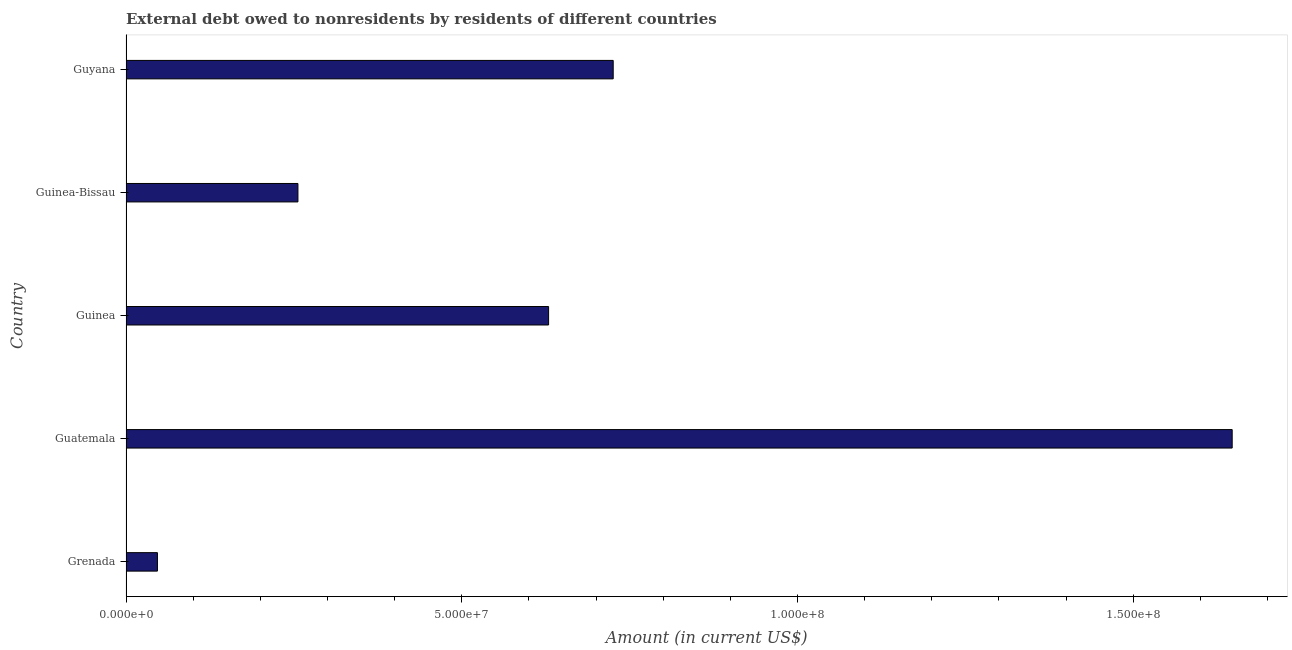Does the graph contain any zero values?
Offer a very short reply. No. Does the graph contain grids?
Ensure brevity in your answer.  No. What is the title of the graph?
Provide a succinct answer. External debt owed to nonresidents by residents of different countries. What is the label or title of the X-axis?
Provide a succinct answer. Amount (in current US$). What is the label or title of the Y-axis?
Offer a terse response. Country. What is the debt in Guinea-Bissau?
Offer a very short reply. 2.56e+07. Across all countries, what is the maximum debt?
Your answer should be very brief. 1.65e+08. Across all countries, what is the minimum debt?
Your response must be concise. 4.68e+06. In which country was the debt maximum?
Your answer should be very brief. Guatemala. In which country was the debt minimum?
Give a very brief answer. Grenada. What is the sum of the debt?
Keep it short and to the point. 3.31e+08. What is the difference between the debt in Guatemala and Guyana?
Your response must be concise. 9.22e+07. What is the average debt per country?
Offer a very short reply. 6.61e+07. What is the median debt?
Ensure brevity in your answer.  6.29e+07. In how many countries, is the debt greater than 60000000 US$?
Keep it short and to the point. 3. What is the ratio of the debt in Grenada to that in Guinea-Bissau?
Offer a terse response. 0.18. What is the difference between the highest and the second highest debt?
Provide a short and direct response. 9.22e+07. What is the difference between the highest and the lowest debt?
Provide a short and direct response. 1.60e+08. How many countries are there in the graph?
Provide a succinct answer. 5. Are the values on the major ticks of X-axis written in scientific E-notation?
Offer a terse response. Yes. What is the Amount (in current US$) of Grenada?
Make the answer very short. 4.68e+06. What is the Amount (in current US$) of Guatemala?
Provide a succinct answer. 1.65e+08. What is the Amount (in current US$) in Guinea?
Ensure brevity in your answer.  6.29e+07. What is the Amount (in current US$) of Guinea-Bissau?
Ensure brevity in your answer.  2.56e+07. What is the Amount (in current US$) of Guyana?
Ensure brevity in your answer.  7.26e+07. What is the difference between the Amount (in current US$) in Grenada and Guatemala?
Offer a terse response. -1.60e+08. What is the difference between the Amount (in current US$) in Grenada and Guinea?
Provide a short and direct response. -5.83e+07. What is the difference between the Amount (in current US$) in Grenada and Guinea-Bissau?
Give a very brief answer. -2.09e+07. What is the difference between the Amount (in current US$) in Grenada and Guyana?
Make the answer very short. -6.79e+07. What is the difference between the Amount (in current US$) in Guatemala and Guinea?
Your response must be concise. 1.02e+08. What is the difference between the Amount (in current US$) in Guatemala and Guinea-Bissau?
Offer a terse response. 1.39e+08. What is the difference between the Amount (in current US$) in Guatemala and Guyana?
Keep it short and to the point. 9.22e+07. What is the difference between the Amount (in current US$) in Guinea and Guinea-Bissau?
Ensure brevity in your answer.  3.73e+07. What is the difference between the Amount (in current US$) in Guinea and Guyana?
Your response must be concise. -9.62e+06. What is the difference between the Amount (in current US$) in Guinea-Bissau and Guyana?
Provide a succinct answer. -4.70e+07. What is the ratio of the Amount (in current US$) in Grenada to that in Guatemala?
Provide a succinct answer. 0.03. What is the ratio of the Amount (in current US$) in Grenada to that in Guinea?
Make the answer very short. 0.07. What is the ratio of the Amount (in current US$) in Grenada to that in Guinea-Bissau?
Provide a succinct answer. 0.18. What is the ratio of the Amount (in current US$) in Grenada to that in Guyana?
Offer a very short reply. 0.07. What is the ratio of the Amount (in current US$) in Guatemala to that in Guinea?
Ensure brevity in your answer.  2.62. What is the ratio of the Amount (in current US$) in Guatemala to that in Guinea-Bissau?
Provide a short and direct response. 6.43. What is the ratio of the Amount (in current US$) in Guatemala to that in Guyana?
Keep it short and to the point. 2.27. What is the ratio of the Amount (in current US$) in Guinea to that in Guinea-Bissau?
Your response must be concise. 2.46. What is the ratio of the Amount (in current US$) in Guinea to that in Guyana?
Make the answer very short. 0.87. What is the ratio of the Amount (in current US$) in Guinea-Bissau to that in Guyana?
Provide a succinct answer. 0.35. 